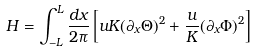Convert formula to latex. <formula><loc_0><loc_0><loc_500><loc_500>H = \int _ { - L } ^ { L } \frac { d x } { 2 \pi } \left [ u K ( \partial _ { x } \Theta ) ^ { 2 } + \frac { u } { K } ( \partial _ { x } \Phi ) ^ { 2 } \right ]</formula> 